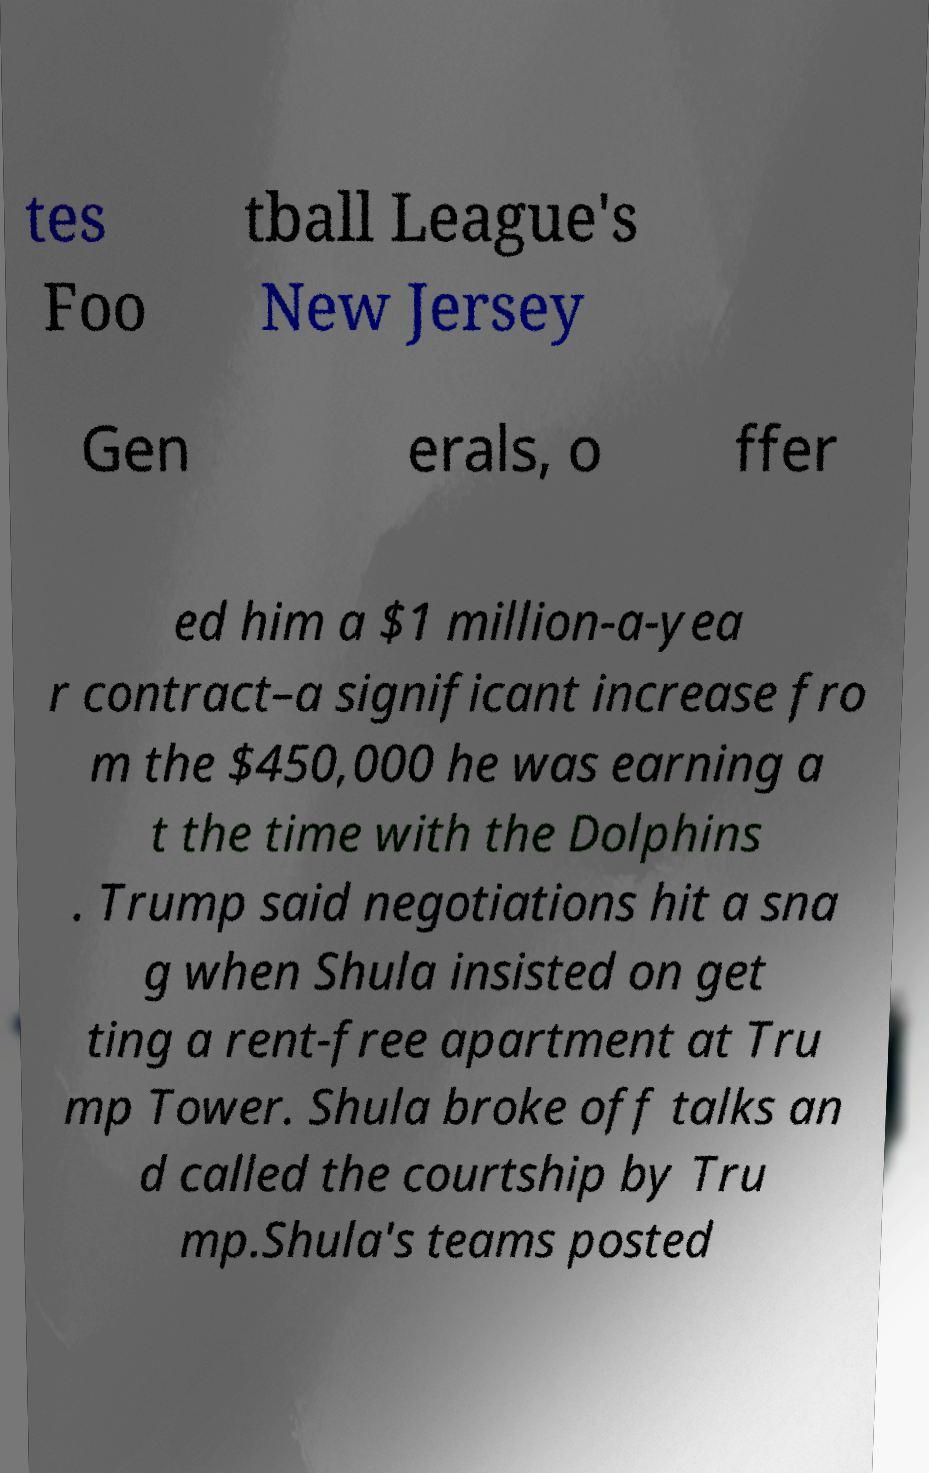Can you read and provide the text displayed in the image?This photo seems to have some interesting text. Can you extract and type it out for me? tes Foo tball League's New Jersey Gen erals, o ffer ed him a $1 million-a-yea r contract–a significant increase fro m the $450,000 he was earning a t the time with the Dolphins . Trump said negotiations hit a sna g when Shula insisted on get ting a rent-free apartment at Tru mp Tower. Shula broke off talks an d called the courtship by Tru mp.Shula's teams posted 